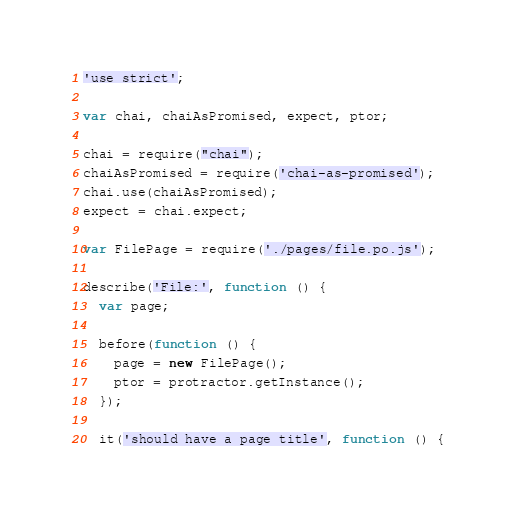<code> <loc_0><loc_0><loc_500><loc_500><_JavaScript_>'use strict';

var chai, chaiAsPromised, expect, ptor;

chai = require("chai");
chaiAsPromised = require('chai-as-promised');
chai.use(chaiAsPromised);
expect = chai.expect;

var FilePage = require('./pages/file.po.js');

describe('File:', function () {
  var page;

  before(function () {
    page = new FilePage();
    ptor = protractor.getInstance();
  });

  it('should have a page title', function () {</code> 